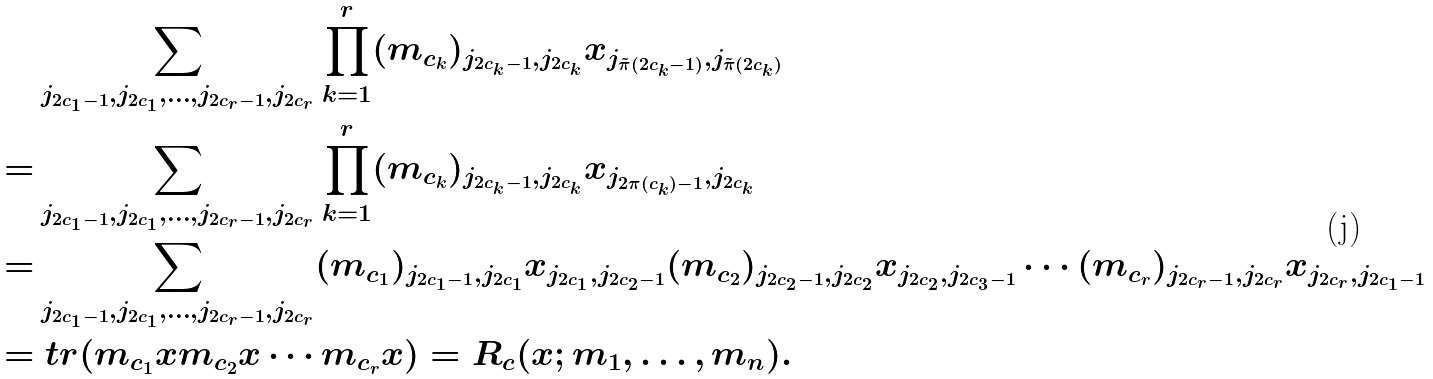<formula> <loc_0><loc_0><loc_500><loc_500>& \sum _ { j _ { 2 c _ { 1 } - 1 } , j _ { 2 c _ { 1 } } , \dots , j _ { 2 c _ { r } - 1 } , j _ { 2 c _ { r } } } \prod _ { k = 1 } ^ { r } ( m _ { c _ { k } } ) _ { j _ { 2 c _ { k } - 1 } , j _ { 2 c _ { k } } } x _ { j _ { \tilde { \pi } ( 2 c _ { k } - 1 ) } , j _ { \tilde { \pi } ( 2 c _ { k } ) } } \\ = & \sum _ { j _ { 2 c _ { 1 } - 1 } , j _ { 2 c _ { 1 } } , \dots , j _ { 2 c _ { r } - 1 } , j _ { 2 c _ { r } } } \prod _ { k = 1 } ^ { r } ( m _ { c _ { k } } ) _ { j _ { 2 c _ { k } - 1 } , j _ { 2 c _ { k } } } x _ { j _ { 2 \pi ( c _ { k } ) - 1 } , j _ { 2 c _ { k } } } \\ = & \sum _ { j _ { 2 c _ { 1 } - 1 } , j _ { 2 c _ { 1 } } , \dots , j _ { 2 c _ { r } - 1 } , j _ { 2 c _ { r } } } ( m _ { c _ { 1 } } ) _ { j _ { 2 c _ { 1 } - 1 } , j _ { 2 c _ { 1 } } } x _ { j _ { 2 c _ { 1 } } , j _ { 2 c _ { 2 } - 1 } } ( m _ { c _ { 2 } } ) _ { j _ { 2 c _ { 2 } - 1 } , j _ { 2 c _ { 2 } } } x _ { j _ { 2 c _ { 2 } } , j _ { 2 c _ { 3 } - 1 } } \cdots ( m _ { c _ { r } } ) _ { j _ { 2 c _ { r } - 1 } , j _ { 2 c _ { r } } } x _ { j _ { 2 c _ { r } } , j _ { 2 c _ { 1 } - 1 } } \\ = & \ t r ( m _ { c _ { 1 } } x m _ { c _ { 2 } } x \cdots m _ { c _ { r } } x ) = R _ { c } ( x ; m _ { 1 } , \dots , m _ { n } ) .</formula> 